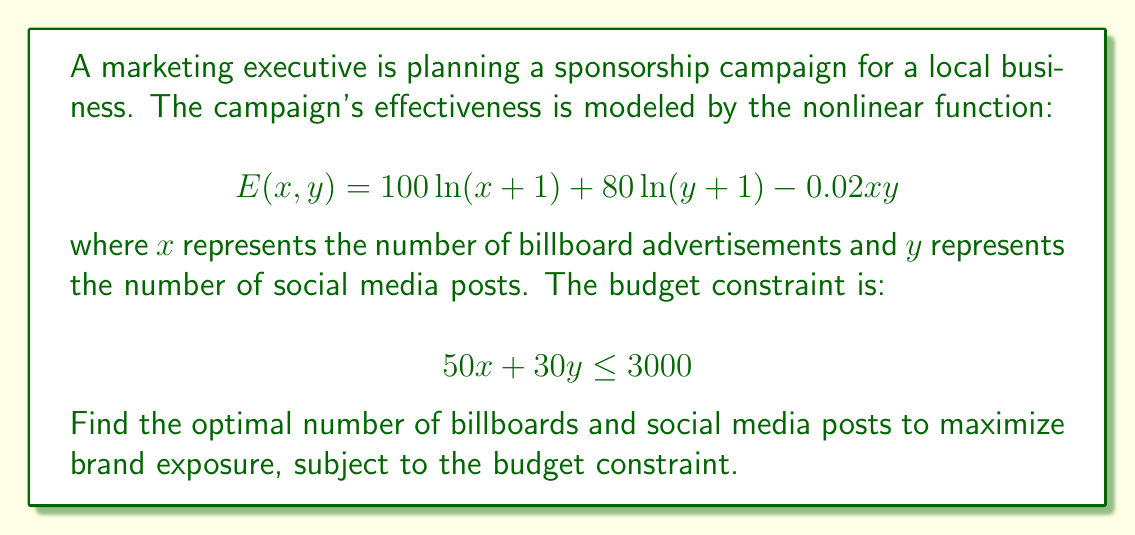Help me with this question. To solve this nonlinear programming problem, we'll use the method of Lagrange multipliers:

1) Define the Lagrangian function:
   $$L(x, y, \lambda) = 100\ln(x+1) + 80\ln(y+1) - 0.02xy + \lambda(3000 - 50x - 30y)$$

2) Calculate partial derivatives and set them to zero:
   $$\frac{\partial L}{\partial x} = \frac{100}{x+1} - 0.02y - 50\lambda = 0$$
   $$\frac{\partial L}{\partial y} = \frac{80}{y+1} - 0.02x - 30\lambda = 0$$
   $$\frac{\partial L}{\partial \lambda} = 3000 - 50x - 30y = 0$$

3) From the first two equations:
   $$\frac{100}{x+1} = 50\lambda + 0.02y$$
   $$\frac{80}{y+1} = 30\lambda + 0.02x$$

4) Multiply these equations by $(x+1)$ and $(y+1)$ respectively:
   $$100 = 50\lambda(x+1) + 0.02y(x+1)$$
   $$80 = 30\lambda(y+1) + 0.02x(y+1)$$

5) Subtract 0.02 times the budget constraint from each:
   $$100 - 60 = 50\lambda(x+1) + 0.02y$$
   $$80 - 60 = 30\lambda(y+1) + 0.02x$$

6) Simplify:
   $$40 = 50\lambda(x+1)$$
   $$20 = 30\lambda(y+1)$$

7) Divide these equations:
   $$\frac{40}{20} = \frac{50(x+1)}{30(y+1)}$$

8) Simplify:
   $$2 = \frac{5(x+1)}{3(y+1)}$$
   $$6(y+1) = 5(x+1)$$
   $$6y + 6 = 5x + 5$$
   $$6y - 5x = -1$$

9) Substitute this into the budget constraint:
   $$50x + 30(\frac{5x-1}{6}) = 3000$$
   $$50x + 25x - 5 = 3000$$
   $$75x = 3005$$
   $$x \approx 40.07$$

10) Substitute back to find y:
    $$6y - 5(40.07) = -1$$
    $$6y = 199.35$$
    $$y \approx 33.23$$

11) Round down to the nearest integer (can't have fractional billboards or posts):
    $x = 40$ and $y = 33$
Answer: 40 billboards, 33 social media posts 